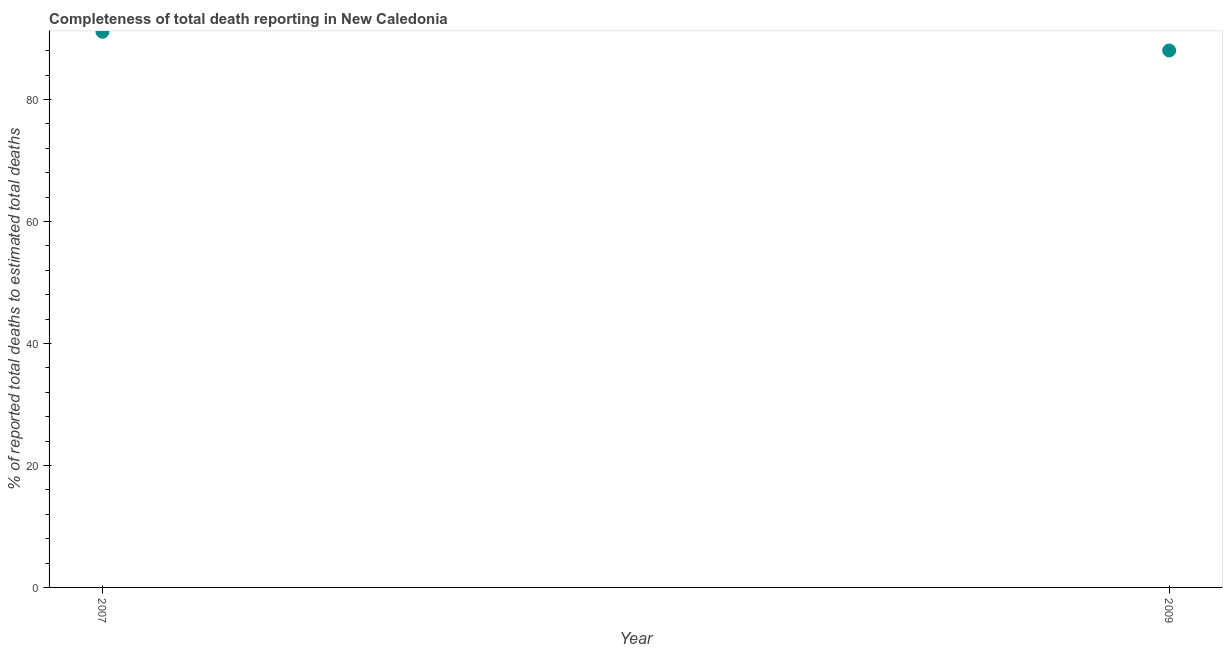What is the completeness of total death reports in 2009?
Ensure brevity in your answer.  88.03. Across all years, what is the maximum completeness of total death reports?
Keep it short and to the point. 91.09. Across all years, what is the minimum completeness of total death reports?
Provide a succinct answer. 88.03. In which year was the completeness of total death reports maximum?
Keep it short and to the point. 2007. What is the sum of the completeness of total death reports?
Make the answer very short. 179.12. What is the difference between the completeness of total death reports in 2007 and 2009?
Offer a very short reply. 3.07. What is the average completeness of total death reports per year?
Your answer should be very brief. 89.56. What is the median completeness of total death reports?
Provide a short and direct response. 89.56. In how many years, is the completeness of total death reports greater than 40 %?
Give a very brief answer. 2. What is the ratio of the completeness of total death reports in 2007 to that in 2009?
Offer a terse response. 1.03. Is the completeness of total death reports in 2007 less than that in 2009?
Offer a very short reply. No. In how many years, is the completeness of total death reports greater than the average completeness of total death reports taken over all years?
Provide a succinct answer. 1. Are the values on the major ticks of Y-axis written in scientific E-notation?
Your answer should be compact. No. Does the graph contain grids?
Give a very brief answer. No. What is the title of the graph?
Keep it short and to the point. Completeness of total death reporting in New Caledonia. What is the label or title of the Y-axis?
Your response must be concise. % of reported total deaths to estimated total deaths. What is the % of reported total deaths to estimated total deaths in 2007?
Provide a short and direct response. 91.09. What is the % of reported total deaths to estimated total deaths in 2009?
Keep it short and to the point. 88.03. What is the difference between the % of reported total deaths to estimated total deaths in 2007 and 2009?
Your response must be concise. 3.07. What is the ratio of the % of reported total deaths to estimated total deaths in 2007 to that in 2009?
Your answer should be compact. 1.03. 